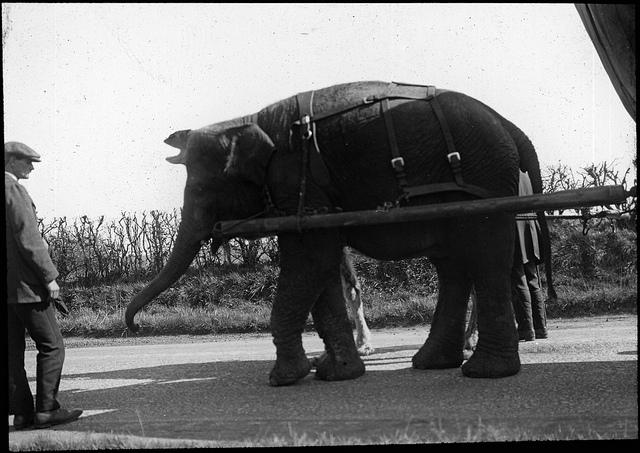Does the elephant need a bath?
Be succinct. No. Is the elephant big?
Quick response, please. Yes. Is the elephant dancing?
Write a very short answer. No. Are there people riding the elephant?
Be succinct. No. What is on the elephant?
Write a very short answer. Harness. What animals are in the picture?
Quick response, please. Elephant. Is this photoshopped?
Give a very brief answer. No. How many  legs does the animal have?
Answer briefly. 4. Are the elephants transporting people?
Be succinct. No. Is the fence taller than the elephant?
Give a very brief answer. No. What is the contraption on the right?
Quick response, please. Cart. Is the elephant pulling a carriage?
Write a very short answer. Yes. 